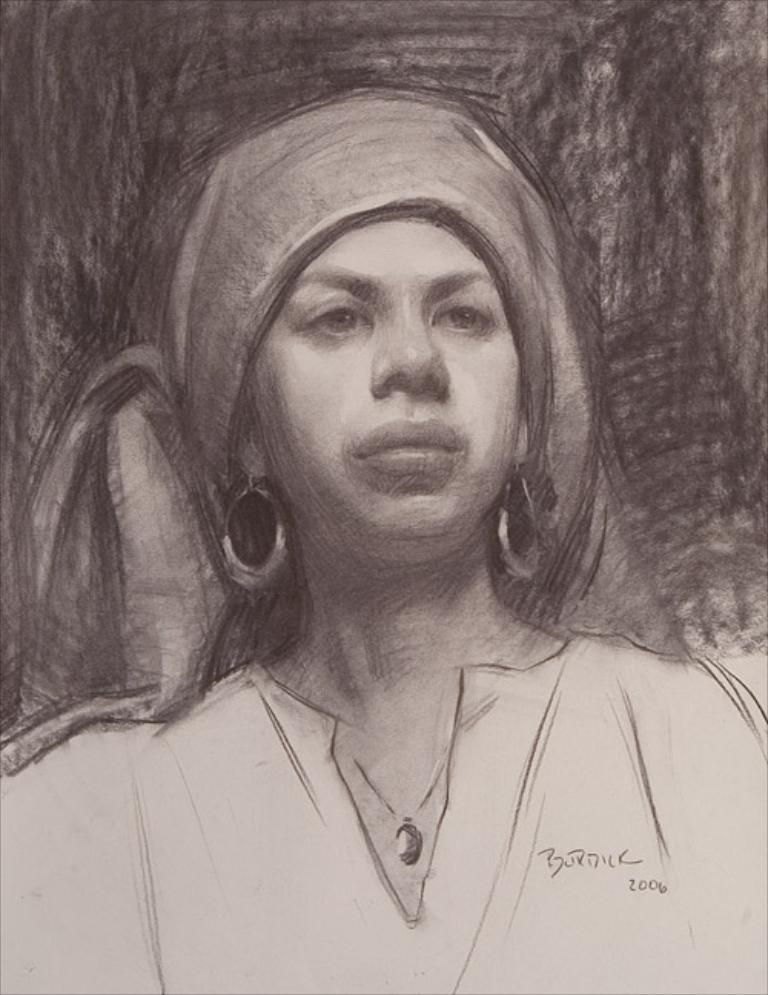What type of artwork is the image? The image is a painting. What is the main subject of the painting? There is a lady depicted in the painting. What is the lady wearing on her head? The lady is wearing a headscarf. How many hands does the lady have in the painting? The number of hands the lady has cannot be determined from the image, as it is a painting and not a photograph. What type of porter is assisting the lady in the painting? There is no porter present in the painting. Can you see the lady's toes in the painting? The lady's toes cannot be seen in the painting, as she is wearing a headscarf and the focus is on her head. 